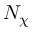<formula> <loc_0><loc_0><loc_500><loc_500>N _ { \chi }</formula> 